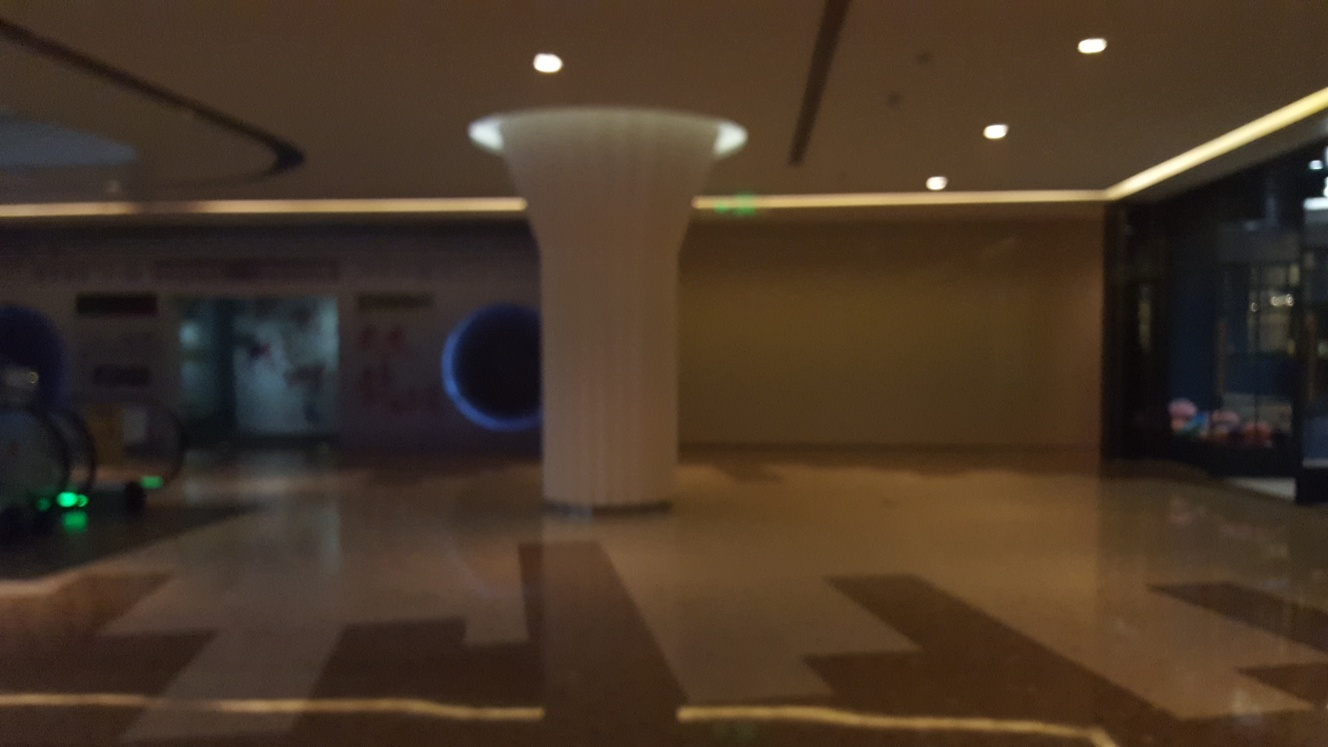What is the overall clarity of the image? A. unclear B. moderate C. very low Answer with the option's letter from the given choices directly. The overall clarity of the image would be best described as 'B. moderate.' Although the image is somewhat blurry, especially towards the edges, the central structure—a pillar—is discernable, and most features can be made out without too much difficulty. 